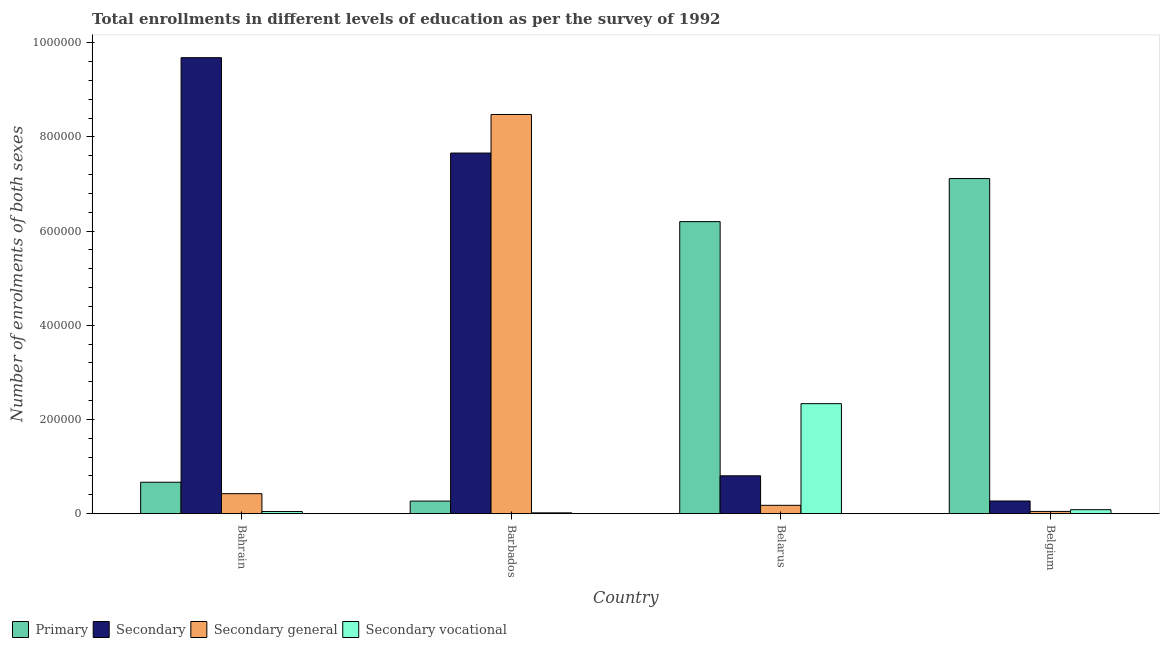What is the label of the 3rd group of bars from the left?
Ensure brevity in your answer.  Belarus. In how many cases, is the number of bars for a given country not equal to the number of legend labels?
Make the answer very short. 0. What is the number of enrolments in secondary vocational education in Bahrain?
Give a very brief answer. 4485. Across all countries, what is the maximum number of enrolments in secondary education?
Give a very brief answer. 9.68e+05. Across all countries, what is the minimum number of enrolments in secondary education?
Your answer should be compact. 2.68e+04. In which country was the number of enrolments in primary education maximum?
Offer a very short reply. Belgium. In which country was the number of enrolments in secondary vocational education minimum?
Offer a terse response. Barbados. What is the total number of enrolments in secondary education in the graph?
Ensure brevity in your answer.  1.84e+06. What is the difference between the number of enrolments in secondary education in Belarus and that in Belgium?
Keep it short and to the point. 5.35e+04. What is the difference between the number of enrolments in secondary education in Bahrain and the number of enrolments in secondary vocational education in Belgium?
Make the answer very short. 9.60e+05. What is the average number of enrolments in secondary general education per country?
Your response must be concise. 2.28e+05. What is the difference between the number of enrolments in secondary education and number of enrolments in secondary general education in Barbados?
Make the answer very short. -8.19e+04. In how many countries, is the number of enrolments in secondary general education greater than 720000 ?
Offer a terse response. 1. What is the ratio of the number of enrolments in secondary general education in Belarus to that in Belgium?
Offer a very short reply. 3.73. What is the difference between the highest and the second highest number of enrolments in secondary vocational education?
Offer a terse response. 2.25e+05. What is the difference between the highest and the lowest number of enrolments in secondary general education?
Your answer should be very brief. 8.43e+05. What does the 3rd bar from the left in Barbados represents?
Your answer should be compact. Secondary general. What does the 3rd bar from the right in Barbados represents?
Give a very brief answer. Secondary. Are all the bars in the graph horizontal?
Your response must be concise. No. How many countries are there in the graph?
Offer a terse response. 4. Does the graph contain any zero values?
Your answer should be very brief. No. Where does the legend appear in the graph?
Provide a short and direct response. Bottom left. How are the legend labels stacked?
Give a very brief answer. Horizontal. What is the title of the graph?
Make the answer very short. Total enrollments in different levels of education as per the survey of 1992. What is the label or title of the X-axis?
Make the answer very short. Country. What is the label or title of the Y-axis?
Offer a very short reply. Number of enrolments of both sexes. What is the Number of enrolments of both sexes in Primary in Bahrain?
Your answer should be compact. 6.67e+04. What is the Number of enrolments of both sexes of Secondary in Bahrain?
Ensure brevity in your answer.  9.68e+05. What is the Number of enrolments of both sexes in Secondary general in Bahrain?
Provide a succinct answer. 4.24e+04. What is the Number of enrolments of both sexes of Secondary vocational in Bahrain?
Offer a very short reply. 4485. What is the Number of enrolments of both sexes of Primary in Barbados?
Offer a very short reply. 2.67e+04. What is the Number of enrolments of both sexes of Secondary in Barbados?
Make the answer very short. 7.66e+05. What is the Number of enrolments of both sexes in Secondary general in Barbados?
Your answer should be compact. 8.48e+05. What is the Number of enrolments of both sexes of Secondary vocational in Barbados?
Ensure brevity in your answer.  1721. What is the Number of enrolments of both sexes in Primary in Belarus?
Make the answer very short. 6.20e+05. What is the Number of enrolments of both sexes of Secondary in Belarus?
Make the answer very short. 8.04e+04. What is the Number of enrolments of both sexes in Secondary general in Belarus?
Your answer should be very brief. 1.77e+04. What is the Number of enrolments of both sexes in Secondary vocational in Belarus?
Ensure brevity in your answer.  2.34e+05. What is the Number of enrolments of both sexes in Primary in Belgium?
Make the answer very short. 7.12e+05. What is the Number of enrolments of both sexes in Secondary in Belgium?
Ensure brevity in your answer.  2.68e+04. What is the Number of enrolments of both sexes in Secondary general in Belgium?
Your answer should be very brief. 4747. What is the Number of enrolments of both sexes in Secondary vocational in Belgium?
Provide a succinct answer. 8372. Across all countries, what is the maximum Number of enrolments of both sexes in Primary?
Your response must be concise. 7.12e+05. Across all countries, what is the maximum Number of enrolments of both sexes in Secondary?
Your response must be concise. 9.68e+05. Across all countries, what is the maximum Number of enrolments of both sexes in Secondary general?
Offer a terse response. 8.48e+05. Across all countries, what is the maximum Number of enrolments of both sexes in Secondary vocational?
Give a very brief answer. 2.34e+05. Across all countries, what is the minimum Number of enrolments of both sexes in Primary?
Give a very brief answer. 2.67e+04. Across all countries, what is the minimum Number of enrolments of both sexes of Secondary?
Provide a short and direct response. 2.68e+04. Across all countries, what is the minimum Number of enrolments of both sexes of Secondary general?
Offer a terse response. 4747. Across all countries, what is the minimum Number of enrolments of both sexes of Secondary vocational?
Provide a short and direct response. 1721. What is the total Number of enrolments of both sexes in Primary in the graph?
Keep it short and to the point. 1.42e+06. What is the total Number of enrolments of both sexes in Secondary in the graph?
Make the answer very short. 1.84e+06. What is the total Number of enrolments of both sexes of Secondary general in the graph?
Make the answer very short. 9.12e+05. What is the total Number of enrolments of both sexes in Secondary vocational in the graph?
Keep it short and to the point. 2.48e+05. What is the difference between the Number of enrolments of both sexes of Primary in Bahrain and that in Barbados?
Offer a terse response. 4.00e+04. What is the difference between the Number of enrolments of both sexes of Secondary in Bahrain and that in Barbados?
Provide a succinct answer. 2.03e+05. What is the difference between the Number of enrolments of both sexes of Secondary general in Bahrain and that in Barbados?
Ensure brevity in your answer.  -8.05e+05. What is the difference between the Number of enrolments of both sexes of Secondary vocational in Bahrain and that in Barbados?
Make the answer very short. 2764. What is the difference between the Number of enrolments of both sexes in Primary in Bahrain and that in Belarus?
Your response must be concise. -5.53e+05. What is the difference between the Number of enrolments of both sexes of Secondary in Bahrain and that in Belarus?
Keep it short and to the point. 8.88e+05. What is the difference between the Number of enrolments of both sexes in Secondary general in Bahrain and that in Belarus?
Make the answer very short. 2.47e+04. What is the difference between the Number of enrolments of both sexes of Secondary vocational in Bahrain and that in Belarus?
Provide a short and direct response. -2.29e+05. What is the difference between the Number of enrolments of both sexes of Primary in Bahrain and that in Belgium?
Offer a very short reply. -6.45e+05. What is the difference between the Number of enrolments of both sexes of Secondary in Bahrain and that in Belgium?
Offer a terse response. 9.41e+05. What is the difference between the Number of enrolments of both sexes in Secondary general in Bahrain and that in Belgium?
Your answer should be very brief. 3.77e+04. What is the difference between the Number of enrolments of both sexes of Secondary vocational in Bahrain and that in Belgium?
Your answer should be compact. -3887. What is the difference between the Number of enrolments of both sexes of Primary in Barbados and that in Belarus?
Offer a terse response. -5.93e+05. What is the difference between the Number of enrolments of both sexes in Secondary in Barbados and that in Belarus?
Offer a very short reply. 6.85e+05. What is the difference between the Number of enrolments of both sexes of Secondary general in Barbados and that in Belarus?
Make the answer very short. 8.30e+05. What is the difference between the Number of enrolments of both sexes in Secondary vocational in Barbados and that in Belarus?
Your answer should be very brief. -2.32e+05. What is the difference between the Number of enrolments of both sexes in Primary in Barbados and that in Belgium?
Keep it short and to the point. -6.85e+05. What is the difference between the Number of enrolments of both sexes of Secondary in Barbados and that in Belgium?
Keep it short and to the point. 7.39e+05. What is the difference between the Number of enrolments of both sexes of Secondary general in Barbados and that in Belgium?
Offer a very short reply. 8.43e+05. What is the difference between the Number of enrolments of both sexes of Secondary vocational in Barbados and that in Belgium?
Your answer should be very brief. -6651. What is the difference between the Number of enrolments of both sexes in Primary in Belarus and that in Belgium?
Offer a very short reply. -9.14e+04. What is the difference between the Number of enrolments of both sexes in Secondary in Belarus and that in Belgium?
Your answer should be compact. 5.35e+04. What is the difference between the Number of enrolments of both sexes of Secondary general in Belarus and that in Belgium?
Provide a succinct answer. 1.29e+04. What is the difference between the Number of enrolments of both sexes of Secondary vocational in Belarus and that in Belgium?
Make the answer very short. 2.25e+05. What is the difference between the Number of enrolments of both sexes in Primary in Bahrain and the Number of enrolments of both sexes in Secondary in Barbados?
Ensure brevity in your answer.  -6.99e+05. What is the difference between the Number of enrolments of both sexes in Primary in Bahrain and the Number of enrolments of both sexes in Secondary general in Barbados?
Give a very brief answer. -7.81e+05. What is the difference between the Number of enrolments of both sexes in Primary in Bahrain and the Number of enrolments of both sexes in Secondary vocational in Barbados?
Keep it short and to the point. 6.50e+04. What is the difference between the Number of enrolments of both sexes in Secondary in Bahrain and the Number of enrolments of both sexes in Secondary general in Barbados?
Offer a very short reply. 1.21e+05. What is the difference between the Number of enrolments of both sexes in Secondary in Bahrain and the Number of enrolments of both sexes in Secondary vocational in Barbados?
Offer a very short reply. 9.66e+05. What is the difference between the Number of enrolments of both sexes in Secondary general in Bahrain and the Number of enrolments of both sexes in Secondary vocational in Barbados?
Give a very brief answer. 4.07e+04. What is the difference between the Number of enrolments of both sexes of Primary in Bahrain and the Number of enrolments of both sexes of Secondary in Belarus?
Provide a succinct answer. -1.37e+04. What is the difference between the Number of enrolments of both sexes in Primary in Bahrain and the Number of enrolments of both sexes in Secondary general in Belarus?
Your answer should be very brief. 4.90e+04. What is the difference between the Number of enrolments of both sexes in Primary in Bahrain and the Number of enrolments of both sexes in Secondary vocational in Belarus?
Provide a short and direct response. -1.67e+05. What is the difference between the Number of enrolments of both sexes in Secondary in Bahrain and the Number of enrolments of both sexes in Secondary general in Belarus?
Ensure brevity in your answer.  9.51e+05. What is the difference between the Number of enrolments of both sexes in Secondary in Bahrain and the Number of enrolments of both sexes in Secondary vocational in Belarus?
Keep it short and to the point. 7.35e+05. What is the difference between the Number of enrolments of both sexes in Secondary general in Bahrain and the Number of enrolments of both sexes in Secondary vocational in Belarus?
Ensure brevity in your answer.  -1.91e+05. What is the difference between the Number of enrolments of both sexes in Primary in Bahrain and the Number of enrolments of both sexes in Secondary in Belgium?
Keep it short and to the point. 3.99e+04. What is the difference between the Number of enrolments of both sexes in Primary in Bahrain and the Number of enrolments of both sexes in Secondary general in Belgium?
Offer a very short reply. 6.19e+04. What is the difference between the Number of enrolments of both sexes in Primary in Bahrain and the Number of enrolments of both sexes in Secondary vocational in Belgium?
Offer a terse response. 5.83e+04. What is the difference between the Number of enrolments of both sexes in Secondary in Bahrain and the Number of enrolments of both sexes in Secondary general in Belgium?
Offer a very short reply. 9.63e+05. What is the difference between the Number of enrolments of both sexes in Secondary in Bahrain and the Number of enrolments of both sexes in Secondary vocational in Belgium?
Give a very brief answer. 9.60e+05. What is the difference between the Number of enrolments of both sexes in Secondary general in Bahrain and the Number of enrolments of both sexes in Secondary vocational in Belgium?
Provide a succinct answer. 3.41e+04. What is the difference between the Number of enrolments of both sexes in Primary in Barbados and the Number of enrolments of both sexes in Secondary in Belarus?
Offer a terse response. -5.37e+04. What is the difference between the Number of enrolments of both sexes of Primary in Barbados and the Number of enrolments of both sexes of Secondary general in Belarus?
Offer a terse response. 8971. What is the difference between the Number of enrolments of both sexes of Primary in Barbados and the Number of enrolments of both sexes of Secondary vocational in Belarus?
Your response must be concise. -2.07e+05. What is the difference between the Number of enrolments of both sexes in Secondary in Barbados and the Number of enrolments of both sexes in Secondary general in Belarus?
Give a very brief answer. 7.48e+05. What is the difference between the Number of enrolments of both sexes in Secondary in Barbados and the Number of enrolments of both sexes in Secondary vocational in Belarus?
Ensure brevity in your answer.  5.32e+05. What is the difference between the Number of enrolments of both sexes in Secondary general in Barbados and the Number of enrolments of both sexes in Secondary vocational in Belarus?
Provide a short and direct response. 6.14e+05. What is the difference between the Number of enrolments of both sexes in Primary in Barbados and the Number of enrolments of both sexes in Secondary in Belgium?
Keep it short and to the point. -174. What is the difference between the Number of enrolments of both sexes in Primary in Barbados and the Number of enrolments of both sexes in Secondary general in Belgium?
Offer a very short reply. 2.19e+04. What is the difference between the Number of enrolments of both sexes of Primary in Barbados and the Number of enrolments of both sexes of Secondary vocational in Belgium?
Your answer should be compact. 1.83e+04. What is the difference between the Number of enrolments of both sexes in Secondary in Barbados and the Number of enrolments of both sexes in Secondary general in Belgium?
Provide a succinct answer. 7.61e+05. What is the difference between the Number of enrolments of both sexes of Secondary in Barbados and the Number of enrolments of both sexes of Secondary vocational in Belgium?
Your answer should be very brief. 7.57e+05. What is the difference between the Number of enrolments of both sexes in Secondary general in Barbados and the Number of enrolments of both sexes in Secondary vocational in Belgium?
Your answer should be very brief. 8.39e+05. What is the difference between the Number of enrolments of both sexes in Primary in Belarus and the Number of enrolments of both sexes in Secondary in Belgium?
Your response must be concise. 5.93e+05. What is the difference between the Number of enrolments of both sexes in Primary in Belarus and the Number of enrolments of both sexes in Secondary general in Belgium?
Keep it short and to the point. 6.15e+05. What is the difference between the Number of enrolments of both sexes in Primary in Belarus and the Number of enrolments of both sexes in Secondary vocational in Belgium?
Provide a short and direct response. 6.12e+05. What is the difference between the Number of enrolments of both sexes of Secondary in Belarus and the Number of enrolments of both sexes of Secondary general in Belgium?
Your response must be concise. 7.56e+04. What is the difference between the Number of enrolments of both sexes of Secondary in Belarus and the Number of enrolments of both sexes of Secondary vocational in Belgium?
Your response must be concise. 7.20e+04. What is the difference between the Number of enrolments of both sexes in Secondary general in Belarus and the Number of enrolments of both sexes in Secondary vocational in Belgium?
Ensure brevity in your answer.  9319. What is the average Number of enrolments of both sexes of Primary per country?
Ensure brevity in your answer.  3.56e+05. What is the average Number of enrolments of both sexes of Secondary per country?
Keep it short and to the point. 4.60e+05. What is the average Number of enrolments of both sexes in Secondary general per country?
Offer a very short reply. 2.28e+05. What is the average Number of enrolments of both sexes of Secondary vocational per country?
Provide a short and direct response. 6.20e+04. What is the difference between the Number of enrolments of both sexes in Primary and Number of enrolments of both sexes in Secondary in Bahrain?
Provide a short and direct response. -9.02e+05. What is the difference between the Number of enrolments of both sexes in Primary and Number of enrolments of both sexes in Secondary general in Bahrain?
Ensure brevity in your answer.  2.43e+04. What is the difference between the Number of enrolments of both sexes in Primary and Number of enrolments of both sexes in Secondary vocational in Bahrain?
Your response must be concise. 6.22e+04. What is the difference between the Number of enrolments of both sexes of Secondary and Number of enrolments of both sexes of Secondary general in Bahrain?
Provide a succinct answer. 9.26e+05. What is the difference between the Number of enrolments of both sexes in Secondary and Number of enrolments of both sexes in Secondary vocational in Bahrain?
Give a very brief answer. 9.64e+05. What is the difference between the Number of enrolments of both sexes in Secondary general and Number of enrolments of both sexes in Secondary vocational in Bahrain?
Give a very brief answer. 3.80e+04. What is the difference between the Number of enrolments of both sexes of Primary and Number of enrolments of both sexes of Secondary in Barbados?
Provide a succinct answer. -7.39e+05. What is the difference between the Number of enrolments of both sexes in Primary and Number of enrolments of both sexes in Secondary general in Barbados?
Provide a short and direct response. -8.21e+05. What is the difference between the Number of enrolments of both sexes of Primary and Number of enrolments of both sexes of Secondary vocational in Barbados?
Offer a terse response. 2.49e+04. What is the difference between the Number of enrolments of both sexes in Secondary and Number of enrolments of both sexes in Secondary general in Barbados?
Keep it short and to the point. -8.19e+04. What is the difference between the Number of enrolments of both sexes of Secondary and Number of enrolments of both sexes of Secondary vocational in Barbados?
Your answer should be compact. 7.64e+05. What is the difference between the Number of enrolments of both sexes in Secondary general and Number of enrolments of both sexes in Secondary vocational in Barbados?
Your response must be concise. 8.46e+05. What is the difference between the Number of enrolments of both sexes in Primary and Number of enrolments of both sexes in Secondary in Belarus?
Offer a very short reply. 5.40e+05. What is the difference between the Number of enrolments of both sexes in Primary and Number of enrolments of both sexes in Secondary general in Belarus?
Your response must be concise. 6.02e+05. What is the difference between the Number of enrolments of both sexes in Primary and Number of enrolments of both sexes in Secondary vocational in Belarus?
Keep it short and to the point. 3.87e+05. What is the difference between the Number of enrolments of both sexes of Secondary and Number of enrolments of both sexes of Secondary general in Belarus?
Ensure brevity in your answer.  6.27e+04. What is the difference between the Number of enrolments of both sexes of Secondary and Number of enrolments of both sexes of Secondary vocational in Belarus?
Provide a succinct answer. -1.53e+05. What is the difference between the Number of enrolments of both sexes of Secondary general and Number of enrolments of both sexes of Secondary vocational in Belarus?
Provide a short and direct response. -2.16e+05. What is the difference between the Number of enrolments of both sexes in Primary and Number of enrolments of both sexes in Secondary in Belgium?
Offer a terse response. 6.85e+05. What is the difference between the Number of enrolments of both sexes in Primary and Number of enrolments of both sexes in Secondary general in Belgium?
Your response must be concise. 7.07e+05. What is the difference between the Number of enrolments of both sexes in Primary and Number of enrolments of both sexes in Secondary vocational in Belgium?
Your answer should be compact. 7.03e+05. What is the difference between the Number of enrolments of both sexes in Secondary and Number of enrolments of both sexes in Secondary general in Belgium?
Ensure brevity in your answer.  2.21e+04. What is the difference between the Number of enrolments of both sexes in Secondary and Number of enrolments of both sexes in Secondary vocational in Belgium?
Give a very brief answer. 1.85e+04. What is the difference between the Number of enrolments of both sexes of Secondary general and Number of enrolments of both sexes of Secondary vocational in Belgium?
Your answer should be compact. -3625. What is the ratio of the Number of enrolments of both sexes of Primary in Bahrain to that in Barbados?
Offer a very short reply. 2.5. What is the ratio of the Number of enrolments of both sexes in Secondary in Bahrain to that in Barbados?
Give a very brief answer. 1.26. What is the ratio of the Number of enrolments of both sexes in Secondary general in Bahrain to that in Barbados?
Provide a short and direct response. 0.05. What is the ratio of the Number of enrolments of both sexes in Secondary vocational in Bahrain to that in Barbados?
Your response must be concise. 2.61. What is the ratio of the Number of enrolments of both sexes of Primary in Bahrain to that in Belarus?
Make the answer very short. 0.11. What is the ratio of the Number of enrolments of both sexes in Secondary in Bahrain to that in Belarus?
Provide a succinct answer. 12.05. What is the ratio of the Number of enrolments of both sexes of Secondary general in Bahrain to that in Belarus?
Your answer should be compact. 2.4. What is the ratio of the Number of enrolments of both sexes of Secondary vocational in Bahrain to that in Belarus?
Keep it short and to the point. 0.02. What is the ratio of the Number of enrolments of both sexes of Primary in Bahrain to that in Belgium?
Ensure brevity in your answer.  0.09. What is the ratio of the Number of enrolments of both sexes of Secondary in Bahrain to that in Belgium?
Provide a succinct answer. 36.08. What is the ratio of the Number of enrolments of both sexes of Secondary general in Bahrain to that in Belgium?
Your answer should be compact. 8.94. What is the ratio of the Number of enrolments of both sexes in Secondary vocational in Bahrain to that in Belgium?
Give a very brief answer. 0.54. What is the ratio of the Number of enrolments of both sexes of Primary in Barbados to that in Belarus?
Ensure brevity in your answer.  0.04. What is the ratio of the Number of enrolments of both sexes of Secondary in Barbados to that in Belarus?
Your answer should be compact. 9.53. What is the ratio of the Number of enrolments of both sexes of Secondary general in Barbados to that in Belarus?
Your answer should be very brief. 47.91. What is the ratio of the Number of enrolments of both sexes in Secondary vocational in Barbados to that in Belarus?
Give a very brief answer. 0.01. What is the ratio of the Number of enrolments of both sexes of Primary in Barbados to that in Belgium?
Your answer should be very brief. 0.04. What is the ratio of the Number of enrolments of both sexes in Secondary in Barbados to that in Belgium?
Ensure brevity in your answer.  28.53. What is the ratio of the Number of enrolments of both sexes in Secondary general in Barbados to that in Belgium?
Provide a short and direct response. 178.55. What is the ratio of the Number of enrolments of both sexes in Secondary vocational in Barbados to that in Belgium?
Provide a short and direct response. 0.21. What is the ratio of the Number of enrolments of both sexes of Primary in Belarus to that in Belgium?
Provide a short and direct response. 0.87. What is the ratio of the Number of enrolments of both sexes in Secondary in Belarus to that in Belgium?
Offer a very short reply. 2.99. What is the ratio of the Number of enrolments of both sexes in Secondary general in Belarus to that in Belgium?
Give a very brief answer. 3.73. What is the ratio of the Number of enrolments of both sexes in Secondary vocational in Belarus to that in Belgium?
Provide a succinct answer. 27.89. What is the difference between the highest and the second highest Number of enrolments of both sexes in Primary?
Offer a terse response. 9.14e+04. What is the difference between the highest and the second highest Number of enrolments of both sexes in Secondary?
Offer a terse response. 2.03e+05. What is the difference between the highest and the second highest Number of enrolments of both sexes in Secondary general?
Your answer should be compact. 8.05e+05. What is the difference between the highest and the second highest Number of enrolments of both sexes of Secondary vocational?
Provide a short and direct response. 2.25e+05. What is the difference between the highest and the lowest Number of enrolments of both sexes in Primary?
Your response must be concise. 6.85e+05. What is the difference between the highest and the lowest Number of enrolments of both sexes of Secondary?
Offer a terse response. 9.41e+05. What is the difference between the highest and the lowest Number of enrolments of both sexes of Secondary general?
Your answer should be compact. 8.43e+05. What is the difference between the highest and the lowest Number of enrolments of both sexes of Secondary vocational?
Offer a very short reply. 2.32e+05. 